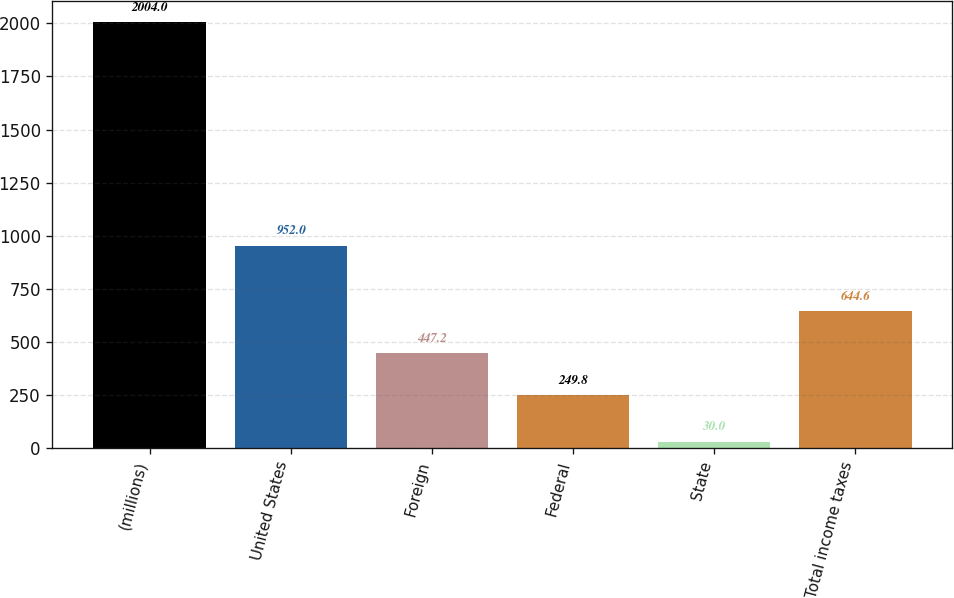Convert chart to OTSL. <chart><loc_0><loc_0><loc_500><loc_500><bar_chart><fcel>(millions)<fcel>United States<fcel>Foreign<fcel>Federal<fcel>State<fcel>Total income taxes<nl><fcel>2004<fcel>952<fcel>447.2<fcel>249.8<fcel>30<fcel>644.6<nl></chart> 